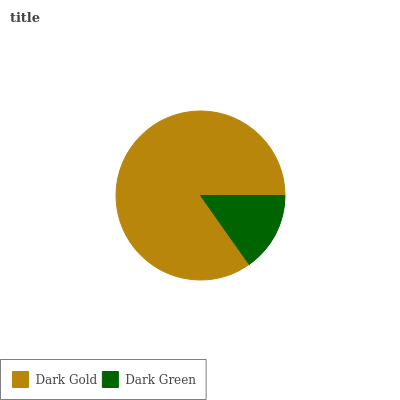Is Dark Green the minimum?
Answer yes or no. Yes. Is Dark Gold the maximum?
Answer yes or no. Yes. Is Dark Green the maximum?
Answer yes or no. No. Is Dark Gold greater than Dark Green?
Answer yes or no. Yes. Is Dark Green less than Dark Gold?
Answer yes or no. Yes. Is Dark Green greater than Dark Gold?
Answer yes or no. No. Is Dark Gold less than Dark Green?
Answer yes or no. No. Is Dark Gold the high median?
Answer yes or no. Yes. Is Dark Green the low median?
Answer yes or no. Yes. Is Dark Green the high median?
Answer yes or no. No. Is Dark Gold the low median?
Answer yes or no. No. 